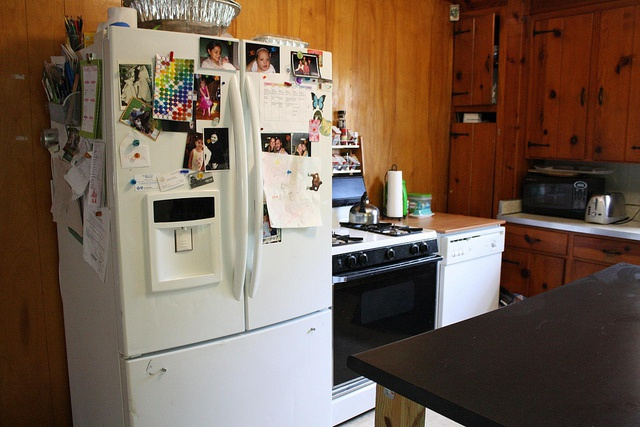Describe the objects in this image and their specific colors. I can see refrigerator in maroon, lightgray, darkgray, gray, and black tones, dining table in maroon, black, and gray tones, oven in maroon, black, white, darkgray, and gray tones, microwave in maroon, black, and gray tones, and oven in maroon, lavender, black, gray, and lightblue tones in this image. 